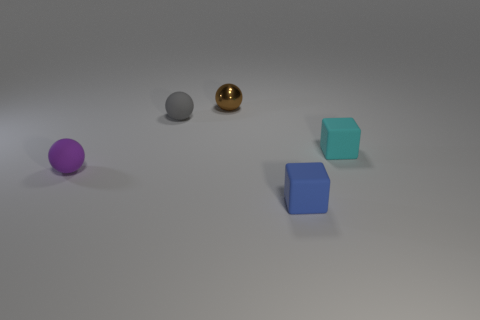Which objects are the same shape and what are the differences between them? The cyan and blue objects share the same cube shape. The main differences between them, aside from color, are their sizes and positions. The cyan cube is smaller and located closer to the viewer than the larger blue cube. And what about their surface texture? Both the cyan and blue cubes have a matte surface texture, which differentiates them from the glossy appearance of the spherical objects. 